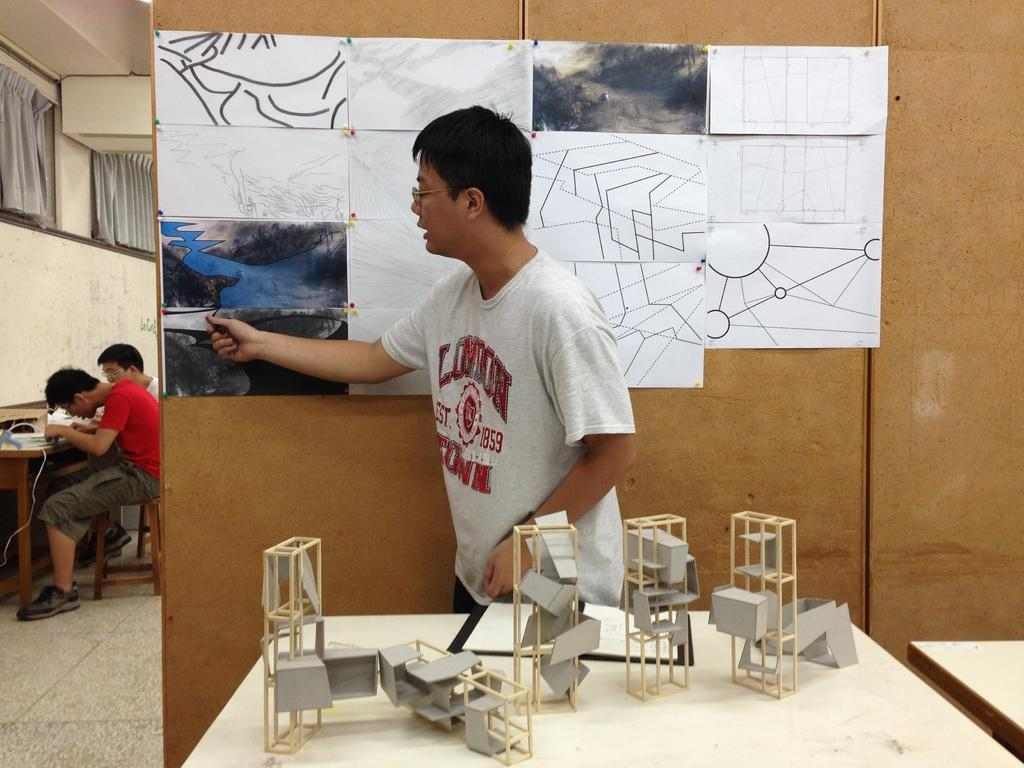What type of structure can be seen in the image? There is a wall in the image. What feature is present on the wall? There is a window in the image. What is covering the window? There are curtains in the image. How many people are visible in the image? There are three people in the image. What piece of furniture can be seen in the image? There is a table in the image. What is the tendency of the milk to spoil in the image? There is no milk present in the image, so it is not possible to determine its tendency to spoil. 